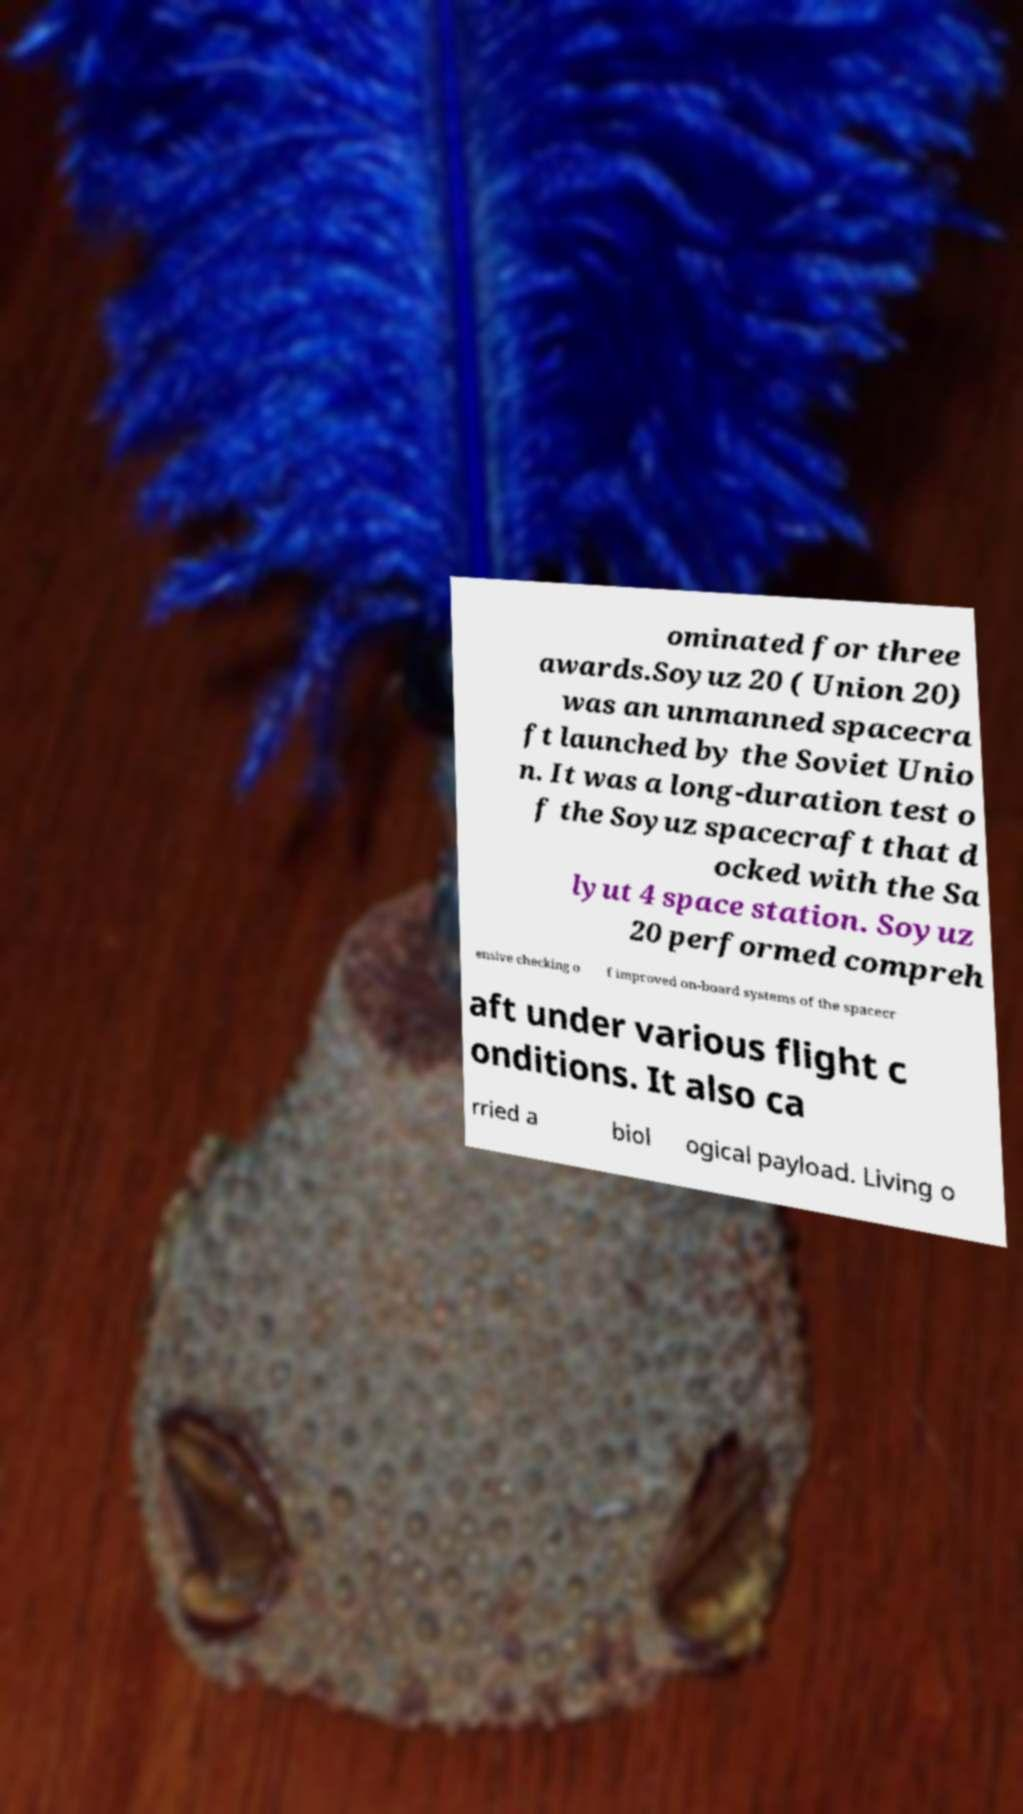Could you assist in decoding the text presented in this image and type it out clearly? ominated for three awards.Soyuz 20 ( Union 20) was an unmanned spacecra ft launched by the Soviet Unio n. It was a long-duration test o f the Soyuz spacecraft that d ocked with the Sa lyut 4 space station. Soyuz 20 performed compreh ensive checking o f improved on-board systems of the spacecr aft under various flight c onditions. It also ca rried a biol ogical payload. Living o 